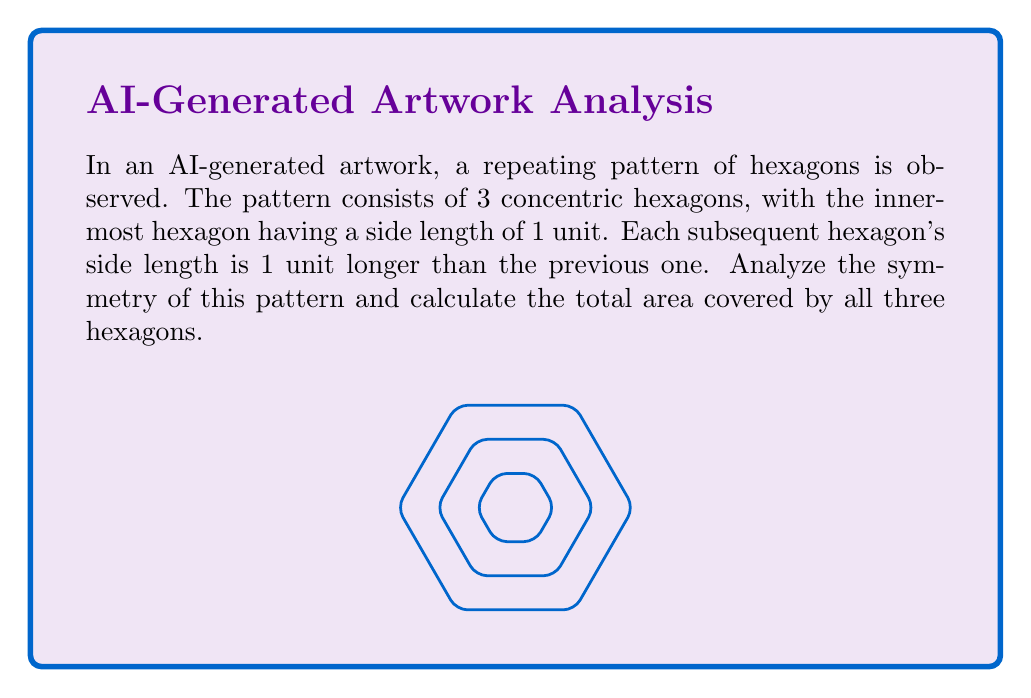Give your solution to this math problem. Let's approach this step-by-step:

1) First, let's consider the symmetry of the pattern:
   - Hexagons have 6-fold rotational symmetry (rotate 60° and it looks the same)
   - They also have 6 lines of reflection symmetry
   - The concentric arrangement preserves all these symmetries

2) Now, let's calculate the area of each hexagon:
   - The area of a regular hexagon with side length $s$ is given by the formula:
     $$A = \frac{3\sqrt{3}}{2}s^2$$

3) Calculate the areas:
   - Innermost hexagon (s = 1): $$A_1 = \frac{3\sqrt{3}}{2}(1)^2 = \frac{3\sqrt{3}}{2}$$
   - Middle hexagon (s = 2): $$A_2 = \frac{3\sqrt{3}}{2}(2)^2 = 6\sqrt{3}$$
   - Outermost hexagon (s = 3): $$A_3 = \frac{3\sqrt{3}}{2}(3)^2 = \frac{27\sqrt{3}}{2}$$

4) Sum up the areas:
   $$A_{total} = A_1 + A_2 + A_3 = \frac{3\sqrt{3}}{2} + 6\sqrt{3} + \frac{27\sqrt{3}}{2}$$
   $$= \frac{3\sqrt{3}}{2} + \frac{12\sqrt{3}}{2} + \frac{27\sqrt{3}}{2} = \frac{42\sqrt{3}}{2} = 21\sqrt{3}$$

Thus, the total area covered by all three hexagons is $21\sqrt{3}$ square units.
Answer: $21\sqrt{3}$ square units 